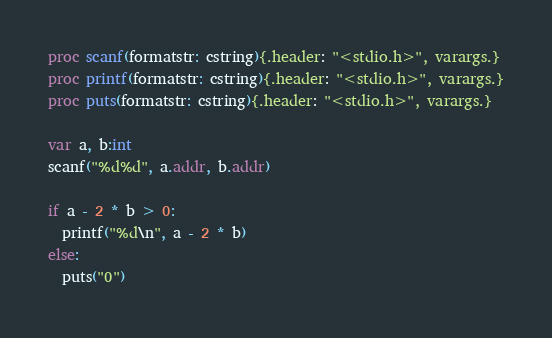Convert code to text. <code><loc_0><loc_0><loc_500><loc_500><_Nim_>proc scanf(formatstr: cstring){.header: "<stdio.h>", varargs.}
proc printf(formatstr: cstring){.header: "<stdio.h>", varargs.}
proc puts(formatstr: cstring){.header: "<stdio.h>", varargs.}

var a, b:int
scanf("%d%d", a.addr, b.addr)

if a - 2 * b > 0:
  printf("%d\n", a - 2 * b)
else:
  puts("0")
</code> 